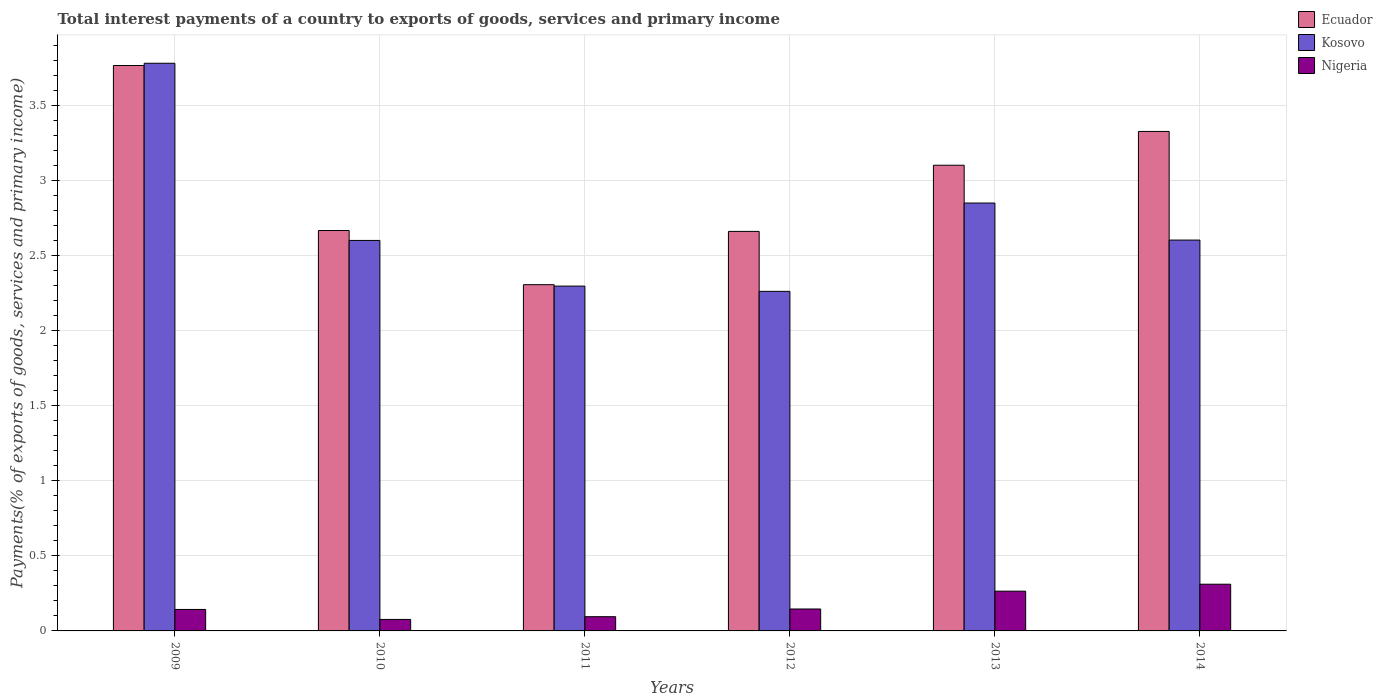Are the number of bars per tick equal to the number of legend labels?
Ensure brevity in your answer.  Yes. Are the number of bars on each tick of the X-axis equal?
Your answer should be compact. Yes. How many bars are there on the 6th tick from the left?
Your answer should be compact. 3. What is the total interest payments in Nigeria in 2009?
Offer a terse response. 0.14. Across all years, what is the maximum total interest payments in Ecuador?
Make the answer very short. 3.77. Across all years, what is the minimum total interest payments in Nigeria?
Offer a terse response. 0.08. In which year was the total interest payments in Nigeria maximum?
Your answer should be very brief. 2014. What is the total total interest payments in Nigeria in the graph?
Keep it short and to the point. 1.04. What is the difference between the total interest payments in Ecuador in 2012 and that in 2013?
Your response must be concise. -0.44. What is the difference between the total interest payments in Nigeria in 2011 and the total interest payments in Kosovo in 2012?
Your response must be concise. -2.17. What is the average total interest payments in Kosovo per year?
Offer a terse response. 2.73. In the year 2009, what is the difference between the total interest payments in Ecuador and total interest payments in Kosovo?
Your answer should be very brief. -0.02. What is the ratio of the total interest payments in Nigeria in 2009 to that in 2013?
Make the answer very short. 0.54. Is the total interest payments in Kosovo in 2009 less than that in 2014?
Give a very brief answer. No. Is the difference between the total interest payments in Ecuador in 2011 and 2013 greater than the difference between the total interest payments in Kosovo in 2011 and 2013?
Keep it short and to the point. No. What is the difference between the highest and the second highest total interest payments in Ecuador?
Your answer should be very brief. 0.44. What is the difference between the highest and the lowest total interest payments in Ecuador?
Keep it short and to the point. 1.46. In how many years, is the total interest payments in Ecuador greater than the average total interest payments in Ecuador taken over all years?
Offer a terse response. 3. Is the sum of the total interest payments in Ecuador in 2010 and 2014 greater than the maximum total interest payments in Kosovo across all years?
Give a very brief answer. Yes. What does the 3rd bar from the left in 2014 represents?
Your answer should be compact. Nigeria. What does the 3rd bar from the right in 2011 represents?
Your response must be concise. Ecuador. Is it the case that in every year, the sum of the total interest payments in Kosovo and total interest payments in Nigeria is greater than the total interest payments in Ecuador?
Provide a short and direct response. No. How many bars are there?
Provide a short and direct response. 18. Are all the bars in the graph horizontal?
Make the answer very short. No. How many years are there in the graph?
Your answer should be compact. 6. Does the graph contain any zero values?
Keep it short and to the point. No. Does the graph contain grids?
Make the answer very short. Yes. Where does the legend appear in the graph?
Provide a succinct answer. Top right. How are the legend labels stacked?
Give a very brief answer. Vertical. What is the title of the graph?
Offer a very short reply. Total interest payments of a country to exports of goods, services and primary income. What is the label or title of the X-axis?
Your response must be concise. Years. What is the label or title of the Y-axis?
Ensure brevity in your answer.  Payments(% of exports of goods, services and primary income). What is the Payments(% of exports of goods, services and primary income) in Ecuador in 2009?
Your answer should be very brief. 3.77. What is the Payments(% of exports of goods, services and primary income) of Kosovo in 2009?
Your response must be concise. 3.78. What is the Payments(% of exports of goods, services and primary income) of Nigeria in 2009?
Ensure brevity in your answer.  0.14. What is the Payments(% of exports of goods, services and primary income) in Ecuador in 2010?
Keep it short and to the point. 2.67. What is the Payments(% of exports of goods, services and primary income) of Kosovo in 2010?
Offer a terse response. 2.6. What is the Payments(% of exports of goods, services and primary income) of Nigeria in 2010?
Offer a terse response. 0.08. What is the Payments(% of exports of goods, services and primary income) of Ecuador in 2011?
Offer a terse response. 2.31. What is the Payments(% of exports of goods, services and primary income) of Kosovo in 2011?
Give a very brief answer. 2.3. What is the Payments(% of exports of goods, services and primary income) in Nigeria in 2011?
Your answer should be compact. 0.09. What is the Payments(% of exports of goods, services and primary income) in Ecuador in 2012?
Provide a short and direct response. 2.66. What is the Payments(% of exports of goods, services and primary income) of Kosovo in 2012?
Your answer should be compact. 2.26. What is the Payments(% of exports of goods, services and primary income) in Nigeria in 2012?
Provide a succinct answer. 0.15. What is the Payments(% of exports of goods, services and primary income) in Ecuador in 2013?
Provide a short and direct response. 3.1. What is the Payments(% of exports of goods, services and primary income) of Kosovo in 2013?
Keep it short and to the point. 2.85. What is the Payments(% of exports of goods, services and primary income) of Nigeria in 2013?
Your answer should be compact. 0.26. What is the Payments(% of exports of goods, services and primary income) of Ecuador in 2014?
Offer a terse response. 3.33. What is the Payments(% of exports of goods, services and primary income) in Kosovo in 2014?
Give a very brief answer. 2.61. What is the Payments(% of exports of goods, services and primary income) in Nigeria in 2014?
Offer a very short reply. 0.31. Across all years, what is the maximum Payments(% of exports of goods, services and primary income) of Ecuador?
Ensure brevity in your answer.  3.77. Across all years, what is the maximum Payments(% of exports of goods, services and primary income) in Kosovo?
Your response must be concise. 3.78. Across all years, what is the maximum Payments(% of exports of goods, services and primary income) of Nigeria?
Your answer should be very brief. 0.31. Across all years, what is the minimum Payments(% of exports of goods, services and primary income) in Ecuador?
Your answer should be compact. 2.31. Across all years, what is the minimum Payments(% of exports of goods, services and primary income) of Kosovo?
Your response must be concise. 2.26. Across all years, what is the minimum Payments(% of exports of goods, services and primary income) of Nigeria?
Keep it short and to the point. 0.08. What is the total Payments(% of exports of goods, services and primary income) of Ecuador in the graph?
Provide a succinct answer. 17.84. What is the total Payments(% of exports of goods, services and primary income) in Kosovo in the graph?
Your response must be concise. 16.41. What is the total Payments(% of exports of goods, services and primary income) of Nigeria in the graph?
Keep it short and to the point. 1.04. What is the difference between the Payments(% of exports of goods, services and primary income) of Ecuador in 2009 and that in 2010?
Offer a very short reply. 1.1. What is the difference between the Payments(% of exports of goods, services and primary income) in Kosovo in 2009 and that in 2010?
Offer a terse response. 1.18. What is the difference between the Payments(% of exports of goods, services and primary income) in Nigeria in 2009 and that in 2010?
Provide a short and direct response. 0.07. What is the difference between the Payments(% of exports of goods, services and primary income) of Ecuador in 2009 and that in 2011?
Keep it short and to the point. 1.46. What is the difference between the Payments(% of exports of goods, services and primary income) of Kosovo in 2009 and that in 2011?
Ensure brevity in your answer.  1.49. What is the difference between the Payments(% of exports of goods, services and primary income) in Nigeria in 2009 and that in 2011?
Provide a short and direct response. 0.05. What is the difference between the Payments(% of exports of goods, services and primary income) of Ecuador in 2009 and that in 2012?
Provide a succinct answer. 1.11. What is the difference between the Payments(% of exports of goods, services and primary income) in Kosovo in 2009 and that in 2012?
Your answer should be very brief. 1.52. What is the difference between the Payments(% of exports of goods, services and primary income) of Nigeria in 2009 and that in 2012?
Ensure brevity in your answer.  -0. What is the difference between the Payments(% of exports of goods, services and primary income) in Ecuador in 2009 and that in 2013?
Ensure brevity in your answer.  0.66. What is the difference between the Payments(% of exports of goods, services and primary income) of Kosovo in 2009 and that in 2013?
Make the answer very short. 0.93. What is the difference between the Payments(% of exports of goods, services and primary income) in Nigeria in 2009 and that in 2013?
Ensure brevity in your answer.  -0.12. What is the difference between the Payments(% of exports of goods, services and primary income) in Ecuador in 2009 and that in 2014?
Keep it short and to the point. 0.44. What is the difference between the Payments(% of exports of goods, services and primary income) in Kosovo in 2009 and that in 2014?
Make the answer very short. 1.18. What is the difference between the Payments(% of exports of goods, services and primary income) in Nigeria in 2009 and that in 2014?
Your answer should be compact. -0.17. What is the difference between the Payments(% of exports of goods, services and primary income) in Ecuador in 2010 and that in 2011?
Offer a very short reply. 0.36. What is the difference between the Payments(% of exports of goods, services and primary income) of Kosovo in 2010 and that in 2011?
Make the answer very short. 0.3. What is the difference between the Payments(% of exports of goods, services and primary income) in Nigeria in 2010 and that in 2011?
Offer a terse response. -0.02. What is the difference between the Payments(% of exports of goods, services and primary income) of Ecuador in 2010 and that in 2012?
Your answer should be very brief. 0.01. What is the difference between the Payments(% of exports of goods, services and primary income) of Kosovo in 2010 and that in 2012?
Offer a terse response. 0.34. What is the difference between the Payments(% of exports of goods, services and primary income) of Nigeria in 2010 and that in 2012?
Ensure brevity in your answer.  -0.07. What is the difference between the Payments(% of exports of goods, services and primary income) of Ecuador in 2010 and that in 2013?
Offer a very short reply. -0.44. What is the difference between the Payments(% of exports of goods, services and primary income) of Kosovo in 2010 and that in 2013?
Your answer should be compact. -0.25. What is the difference between the Payments(% of exports of goods, services and primary income) of Nigeria in 2010 and that in 2013?
Your answer should be very brief. -0.19. What is the difference between the Payments(% of exports of goods, services and primary income) of Ecuador in 2010 and that in 2014?
Keep it short and to the point. -0.66. What is the difference between the Payments(% of exports of goods, services and primary income) of Kosovo in 2010 and that in 2014?
Provide a succinct answer. -0. What is the difference between the Payments(% of exports of goods, services and primary income) in Nigeria in 2010 and that in 2014?
Provide a succinct answer. -0.23. What is the difference between the Payments(% of exports of goods, services and primary income) in Ecuador in 2011 and that in 2012?
Your answer should be very brief. -0.36. What is the difference between the Payments(% of exports of goods, services and primary income) in Kosovo in 2011 and that in 2012?
Give a very brief answer. 0.04. What is the difference between the Payments(% of exports of goods, services and primary income) in Nigeria in 2011 and that in 2012?
Make the answer very short. -0.05. What is the difference between the Payments(% of exports of goods, services and primary income) in Ecuador in 2011 and that in 2013?
Your answer should be compact. -0.8. What is the difference between the Payments(% of exports of goods, services and primary income) of Kosovo in 2011 and that in 2013?
Your response must be concise. -0.55. What is the difference between the Payments(% of exports of goods, services and primary income) in Nigeria in 2011 and that in 2013?
Keep it short and to the point. -0.17. What is the difference between the Payments(% of exports of goods, services and primary income) of Ecuador in 2011 and that in 2014?
Make the answer very short. -1.02. What is the difference between the Payments(% of exports of goods, services and primary income) of Kosovo in 2011 and that in 2014?
Keep it short and to the point. -0.31. What is the difference between the Payments(% of exports of goods, services and primary income) in Nigeria in 2011 and that in 2014?
Give a very brief answer. -0.22. What is the difference between the Payments(% of exports of goods, services and primary income) in Ecuador in 2012 and that in 2013?
Your answer should be compact. -0.44. What is the difference between the Payments(% of exports of goods, services and primary income) in Kosovo in 2012 and that in 2013?
Offer a very short reply. -0.59. What is the difference between the Payments(% of exports of goods, services and primary income) in Nigeria in 2012 and that in 2013?
Keep it short and to the point. -0.12. What is the difference between the Payments(% of exports of goods, services and primary income) of Ecuador in 2012 and that in 2014?
Make the answer very short. -0.67. What is the difference between the Payments(% of exports of goods, services and primary income) of Kosovo in 2012 and that in 2014?
Give a very brief answer. -0.34. What is the difference between the Payments(% of exports of goods, services and primary income) in Nigeria in 2012 and that in 2014?
Offer a terse response. -0.17. What is the difference between the Payments(% of exports of goods, services and primary income) in Ecuador in 2013 and that in 2014?
Keep it short and to the point. -0.23. What is the difference between the Payments(% of exports of goods, services and primary income) in Kosovo in 2013 and that in 2014?
Your response must be concise. 0.25. What is the difference between the Payments(% of exports of goods, services and primary income) of Nigeria in 2013 and that in 2014?
Ensure brevity in your answer.  -0.05. What is the difference between the Payments(% of exports of goods, services and primary income) in Ecuador in 2009 and the Payments(% of exports of goods, services and primary income) in Kosovo in 2010?
Provide a short and direct response. 1.17. What is the difference between the Payments(% of exports of goods, services and primary income) in Ecuador in 2009 and the Payments(% of exports of goods, services and primary income) in Nigeria in 2010?
Make the answer very short. 3.69. What is the difference between the Payments(% of exports of goods, services and primary income) in Kosovo in 2009 and the Payments(% of exports of goods, services and primary income) in Nigeria in 2010?
Offer a terse response. 3.71. What is the difference between the Payments(% of exports of goods, services and primary income) of Ecuador in 2009 and the Payments(% of exports of goods, services and primary income) of Kosovo in 2011?
Offer a terse response. 1.47. What is the difference between the Payments(% of exports of goods, services and primary income) in Ecuador in 2009 and the Payments(% of exports of goods, services and primary income) in Nigeria in 2011?
Offer a terse response. 3.67. What is the difference between the Payments(% of exports of goods, services and primary income) of Kosovo in 2009 and the Payments(% of exports of goods, services and primary income) of Nigeria in 2011?
Offer a terse response. 3.69. What is the difference between the Payments(% of exports of goods, services and primary income) of Ecuador in 2009 and the Payments(% of exports of goods, services and primary income) of Kosovo in 2012?
Provide a short and direct response. 1.51. What is the difference between the Payments(% of exports of goods, services and primary income) of Ecuador in 2009 and the Payments(% of exports of goods, services and primary income) of Nigeria in 2012?
Your answer should be very brief. 3.62. What is the difference between the Payments(% of exports of goods, services and primary income) in Kosovo in 2009 and the Payments(% of exports of goods, services and primary income) in Nigeria in 2012?
Provide a short and direct response. 3.64. What is the difference between the Payments(% of exports of goods, services and primary income) in Ecuador in 2009 and the Payments(% of exports of goods, services and primary income) in Nigeria in 2013?
Your response must be concise. 3.5. What is the difference between the Payments(% of exports of goods, services and primary income) of Kosovo in 2009 and the Payments(% of exports of goods, services and primary income) of Nigeria in 2013?
Ensure brevity in your answer.  3.52. What is the difference between the Payments(% of exports of goods, services and primary income) in Ecuador in 2009 and the Payments(% of exports of goods, services and primary income) in Kosovo in 2014?
Your answer should be compact. 1.16. What is the difference between the Payments(% of exports of goods, services and primary income) in Ecuador in 2009 and the Payments(% of exports of goods, services and primary income) in Nigeria in 2014?
Your answer should be very brief. 3.46. What is the difference between the Payments(% of exports of goods, services and primary income) of Kosovo in 2009 and the Payments(% of exports of goods, services and primary income) of Nigeria in 2014?
Offer a very short reply. 3.47. What is the difference between the Payments(% of exports of goods, services and primary income) of Ecuador in 2010 and the Payments(% of exports of goods, services and primary income) of Kosovo in 2011?
Offer a very short reply. 0.37. What is the difference between the Payments(% of exports of goods, services and primary income) of Ecuador in 2010 and the Payments(% of exports of goods, services and primary income) of Nigeria in 2011?
Give a very brief answer. 2.57. What is the difference between the Payments(% of exports of goods, services and primary income) in Kosovo in 2010 and the Payments(% of exports of goods, services and primary income) in Nigeria in 2011?
Provide a succinct answer. 2.51. What is the difference between the Payments(% of exports of goods, services and primary income) of Ecuador in 2010 and the Payments(% of exports of goods, services and primary income) of Kosovo in 2012?
Make the answer very short. 0.41. What is the difference between the Payments(% of exports of goods, services and primary income) in Ecuador in 2010 and the Payments(% of exports of goods, services and primary income) in Nigeria in 2012?
Provide a short and direct response. 2.52. What is the difference between the Payments(% of exports of goods, services and primary income) in Kosovo in 2010 and the Payments(% of exports of goods, services and primary income) in Nigeria in 2012?
Offer a terse response. 2.46. What is the difference between the Payments(% of exports of goods, services and primary income) of Ecuador in 2010 and the Payments(% of exports of goods, services and primary income) of Kosovo in 2013?
Offer a very short reply. -0.18. What is the difference between the Payments(% of exports of goods, services and primary income) of Ecuador in 2010 and the Payments(% of exports of goods, services and primary income) of Nigeria in 2013?
Give a very brief answer. 2.4. What is the difference between the Payments(% of exports of goods, services and primary income) of Kosovo in 2010 and the Payments(% of exports of goods, services and primary income) of Nigeria in 2013?
Ensure brevity in your answer.  2.34. What is the difference between the Payments(% of exports of goods, services and primary income) in Ecuador in 2010 and the Payments(% of exports of goods, services and primary income) in Kosovo in 2014?
Ensure brevity in your answer.  0.06. What is the difference between the Payments(% of exports of goods, services and primary income) in Ecuador in 2010 and the Payments(% of exports of goods, services and primary income) in Nigeria in 2014?
Your response must be concise. 2.36. What is the difference between the Payments(% of exports of goods, services and primary income) of Kosovo in 2010 and the Payments(% of exports of goods, services and primary income) of Nigeria in 2014?
Provide a short and direct response. 2.29. What is the difference between the Payments(% of exports of goods, services and primary income) in Ecuador in 2011 and the Payments(% of exports of goods, services and primary income) in Kosovo in 2012?
Your response must be concise. 0.04. What is the difference between the Payments(% of exports of goods, services and primary income) of Ecuador in 2011 and the Payments(% of exports of goods, services and primary income) of Nigeria in 2012?
Provide a short and direct response. 2.16. What is the difference between the Payments(% of exports of goods, services and primary income) of Kosovo in 2011 and the Payments(% of exports of goods, services and primary income) of Nigeria in 2012?
Give a very brief answer. 2.15. What is the difference between the Payments(% of exports of goods, services and primary income) in Ecuador in 2011 and the Payments(% of exports of goods, services and primary income) in Kosovo in 2013?
Make the answer very short. -0.54. What is the difference between the Payments(% of exports of goods, services and primary income) of Ecuador in 2011 and the Payments(% of exports of goods, services and primary income) of Nigeria in 2013?
Make the answer very short. 2.04. What is the difference between the Payments(% of exports of goods, services and primary income) in Kosovo in 2011 and the Payments(% of exports of goods, services and primary income) in Nigeria in 2013?
Your answer should be compact. 2.03. What is the difference between the Payments(% of exports of goods, services and primary income) in Ecuador in 2011 and the Payments(% of exports of goods, services and primary income) in Kosovo in 2014?
Keep it short and to the point. -0.3. What is the difference between the Payments(% of exports of goods, services and primary income) in Ecuador in 2011 and the Payments(% of exports of goods, services and primary income) in Nigeria in 2014?
Provide a short and direct response. 2. What is the difference between the Payments(% of exports of goods, services and primary income) of Kosovo in 2011 and the Payments(% of exports of goods, services and primary income) of Nigeria in 2014?
Ensure brevity in your answer.  1.99. What is the difference between the Payments(% of exports of goods, services and primary income) in Ecuador in 2012 and the Payments(% of exports of goods, services and primary income) in Kosovo in 2013?
Make the answer very short. -0.19. What is the difference between the Payments(% of exports of goods, services and primary income) in Ecuador in 2012 and the Payments(% of exports of goods, services and primary income) in Nigeria in 2013?
Your answer should be very brief. 2.4. What is the difference between the Payments(% of exports of goods, services and primary income) of Kosovo in 2012 and the Payments(% of exports of goods, services and primary income) of Nigeria in 2013?
Ensure brevity in your answer.  2. What is the difference between the Payments(% of exports of goods, services and primary income) in Ecuador in 2012 and the Payments(% of exports of goods, services and primary income) in Kosovo in 2014?
Provide a succinct answer. 0.06. What is the difference between the Payments(% of exports of goods, services and primary income) in Ecuador in 2012 and the Payments(% of exports of goods, services and primary income) in Nigeria in 2014?
Provide a succinct answer. 2.35. What is the difference between the Payments(% of exports of goods, services and primary income) in Kosovo in 2012 and the Payments(% of exports of goods, services and primary income) in Nigeria in 2014?
Your response must be concise. 1.95. What is the difference between the Payments(% of exports of goods, services and primary income) in Ecuador in 2013 and the Payments(% of exports of goods, services and primary income) in Kosovo in 2014?
Ensure brevity in your answer.  0.5. What is the difference between the Payments(% of exports of goods, services and primary income) in Ecuador in 2013 and the Payments(% of exports of goods, services and primary income) in Nigeria in 2014?
Provide a succinct answer. 2.79. What is the difference between the Payments(% of exports of goods, services and primary income) of Kosovo in 2013 and the Payments(% of exports of goods, services and primary income) of Nigeria in 2014?
Give a very brief answer. 2.54. What is the average Payments(% of exports of goods, services and primary income) in Ecuador per year?
Your answer should be compact. 2.97. What is the average Payments(% of exports of goods, services and primary income) in Kosovo per year?
Your response must be concise. 2.73. What is the average Payments(% of exports of goods, services and primary income) of Nigeria per year?
Offer a terse response. 0.17. In the year 2009, what is the difference between the Payments(% of exports of goods, services and primary income) of Ecuador and Payments(% of exports of goods, services and primary income) of Kosovo?
Ensure brevity in your answer.  -0.01. In the year 2009, what is the difference between the Payments(% of exports of goods, services and primary income) in Ecuador and Payments(% of exports of goods, services and primary income) in Nigeria?
Your answer should be very brief. 3.63. In the year 2009, what is the difference between the Payments(% of exports of goods, services and primary income) in Kosovo and Payments(% of exports of goods, services and primary income) in Nigeria?
Give a very brief answer. 3.64. In the year 2010, what is the difference between the Payments(% of exports of goods, services and primary income) in Ecuador and Payments(% of exports of goods, services and primary income) in Kosovo?
Your answer should be very brief. 0.07. In the year 2010, what is the difference between the Payments(% of exports of goods, services and primary income) in Ecuador and Payments(% of exports of goods, services and primary income) in Nigeria?
Provide a succinct answer. 2.59. In the year 2010, what is the difference between the Payments(% of exports of goods, services and primary income) of Kosovo and Payments(% of exports of goods, services and primary income) of Nigeria?
Offer a terse response. 2.53. In the year 2011, what is the difference between the Payments(% of exports of goods, services and primary income) of Ecuador and Payments(% of exports of goods, services and primary income) of Kosovo?
Ensure brevity in your answer.  0.01. In the year 2011, what is the difference between the Payments(% of exports of goods, services and primary income) in Ecuador and Payments(% of exports of goods, services and primary income) in Nigeria?
Keep it short and to the point. 2.21. In the year 2011, what is the difference between the Payments(% of exports of goods, services and primary income) of Kosovo and Payments(% of exports of goods, services and primary income) of Nigeria?
Your response must be concise. 2.2. In the year 2012, what is the difference between the Payments(% of exports of goods, services and primary income) in Ecuador and Payments(% of exports of goods, services and primary income) in Kosovo?
Your answer should be compact. 0.4. In the year 2012, what is the difference between the Payments(% of exports of goods, services and primary income) in Ecuador and Payments(% of exports of goods, services and primary income) in Nigeria?
Your answer should be very brief. 2.52. In the year 2012, what is the difference between the Payments(% of exports of goods, services and primary income) in Kosovo and Payments(% of exports of goods, services and primary income) in Nigeria?
Your answer should be compact. 2.12. In the year 2013, what is the difference between the Payments(% of exports of goods, services and primary income) of Ecuador and Payments(% of exports of goods, services and primary income) of Kosovo?
Make the answer very short. 0.25. In the year 2013, what is the difference between the Payments(% of exports of goods, services and primary income) of Ecuador and Payments(% of exports of goods, services and primary income) of Nigeria?
Ensure brevity in your answer.  2.84. In the year 2013, what is the difference between the Payments(% of exports of goods, services and primary income) in Kosovo and Payments(% of exports of goods, services and primary income) in Nigeria?
Keep it short and to the point. 2.59. In the year 2014, what is the difference between the Payments(% of exports of goods, services and primary income) of Ecuador and Payments(% of exports of goods, services and primary income) of Kosovo?
Give a very brief answer. 0.72. In the year 2014, what is the difference between the Payments(% of exports of goods, services and primary income) in Ecuador and Payments(% of exports of goods, services and primary income) in Nigeria?
Provide a short and direct response. 3.02. In the year 2014, what is the difference between the Payments(% of exports of goods, services and primary income) of Kosovo and Payments(% of exports of goods, services and primary income) of Nigeria?
Make the answer very short. 2.29. What is the ratio of the Payments(% of exports of goods, services and primary income) of Ecuador in 2009 to that in 2010?
Offer a terse response. 1.41. What is the ratio of the Payments(% of exports of goods, services and primary income) of Kosovo in 2009 to that in 2010?
Keep it short and to the point. 1.45. What is the ratio of the Payments(% of exports of goods, services and primary income) in Nigeria in 2009 to that in 2010?
Provide a succinct answer. 1.87. What is the ratio of the Payments(% of exports of goods, services and primary income) in Ecuador in 2009 to that in 2011?
Offer a very short reply. 1.63. What is the ratio of the Payments(% of exports of goods, services and primary income) of Kosovo in 2009 to that in 2011?
Your answer should be very brief. 1.65. What is the ratio of the Payments(% of exports of goods, services and primary income) in Nigeria in 2009 to that in 2011?
Provide a succinct answer. 1.51. What is the ratio of the Payments(% of exports of goods, services and primary income) in Ecuador in 2009 to that in 2012?
Provide a short and direct response. 1.42. What is the ratio of the Payments(% of exports of goods, services and primary income) of Kosovo in 2009 to that in 2012?
Provide a succinct answer. 1.67. What is the ratio of the Payments(% of exports of goods, services and primary income) in Nigeria in 2009 to that in 2012?
Give a very brief answer. 0.98. What is the ratio of the Payments(% of exports of goods, services and primary income) in Ecuador in 2009 to that in 2013?
Offer a very short reply. 1.21. What is the ratio of the Payments(% of exports of goods, services and primary income) in Kosovo in 2009 to that in 2013?
Your answer should be compact. 1.33. What is the ratio of the Payments(% of exports of goods, services and primary income) in Nigeria in 2009 to that in 2013?
Your answer should be compact. 0.54. What is the ratio of the Payments(% of exports of goods, services and primary income) in Ecuador in 2009 to that in 2014?
Give a very brief answer. 1.13. What is the ratio of the Payments(% of exports of goods, services and primary income) of Kosovo in 2009 to that in 2014?
Give a very brief answer. 1.45. What is the ratio of the Payments(% of exports of goods, services and primary income) of Nigeria in 2009 to that in 2014?
Keep it short and to the point. 0.46. What is the ratio of the Payments(% of exports of goods, services and primary income) of Ecuador in 2010 to that in 2011?
Your answer should be very brief. 1.16. What is the ratio of the Payments(% of exports of goods, services and primary income) of Kosovo in 2010 to that in 2011?
Your answer should be compact. 1.13. What is the ratio of the Payments(% of exports of goods, services and primary income) in Nigeria in 2010 to that in 2011?
Provide a succinct answer. 0.81. What is the ratio of the Payments(% of exports of goods, services and primary income) of Ecuador in 2010 to that in 2012?
Make the answer very short. 1. What is the ratio of the Payments(% of exports of goods, services and primary income) in Kosovo in 2010 to that in 2012?
Give a very brief answer. 1.15. What is the ratio of the Payments(% of exports of goods, services and primary income) of Nigeria in 2010 to that in 2012?
Provide a short and direct response. 0.52. What is the ratio of the Payments(% of exports of goods, services and primary income) in Ecuador in 2010 to that in 2013?
Provide a short and direct response. 0.86. What is the ratio of the Payments(% of exports of goods, services and primary income) in Kosovo in 2010 to that in 2013?
Offer a terse response. 0.91. What is the ratio of the Payments(% of exports of goods, services and primary income) in Nigeria in 2010 to that in 2013?
Offer a terse response. 0.29. What is the ratio of the Payments(% of exports of goods, services and primary income) of Ecuador in 2010 to that in 2014?
Provide a succinct answer. 0.8. What is the ratio of the Payments(% of exports of goods, services and primary income) in Nigeria in 2010 to that in 2014?
Make the answer very short. 0.25. What is the ratio of the Payments(% of exports of goods, services and primary income) in Ecuador in 2011 to that in 2012?
Your answer should be compact. 0.87. What is the ratio of the Payments(% of exports of goods, services and primary income) of Kosovo in 2011 to that in 2012?
Offer a very short reply. 1.02. What is the ratio of the Payments(% of exports of goods, services and primary income) in Nigeria in 2011 to that in 2012?
Provide a short and direct response. 0.65. What is the ratio of the Payments(% of exports of goods, services and primary income) of Ecuador in 2011 to that in 2013?
Your response must be concise. 0.74. What is the ratio of the Payments(% of exports of goods, services and primary income) of Kosovo in 2011 to that in 2013?
Your answer should be very brief. 0.81. What is the ratio of the Payments(% of exports of goods, services and primary income) of Nigeria in 2011 to that in 2013?
Offer a terse response. 0.36. What is the ratio of the Payments(% of exports of goods, services and primary income) in Ecuador in 2011 to that in 2014?
Offer a very short reply. 0.69. What is the ratio of the Payments(% of exports of goods, services and primary income) of Kosovo in 2011 to that in 2014?
Your answer should be very brief. 0.88. What is the ratio of the Payments(% of exports of goods, services and primary income) of Nigeria in 2011 to that in 2014?
Your answer should be very brief. 0.3. What is the ratio of the Payments(% of exports of goods, services and primary income) of Ecuador in 2012 to that in 2013?
Your answer should be very brief. 0.86. What is the ratio of the Payments(% of exports of goods, services and primary income) in Kosovo in 2012 to that in 2013?
Make the answer very short. 0.79. What is the ratio of the Payments(% of exports of goods, services and primary income) of Nigeria in 2012 to that in 2013?
Your answer should be very brief. 0.55. What is the ratio of the Payments(% of exports of goods, services and primary income) of Ecuador in 2012 to that in 2014?
Ensure brevity in your answer.  0.8. What is the ratio of the Payments(% of exports of goods, services and primary income) in Kosovo in 2012 to that in 2014?
Your answer should be compact. 0.87. What is the ratio of the Payments(% of exports of goods, services and primary income) of Nigeria in 2012 to that in 2014?
Ensure brevity in your answer.  0.47. What is the ratio of the Payments(% of exports of goods, services and primary income) in Ecuador in 2013 to that in 2014?
Your answer should be compact. 0.93. What is the ratio of the Payments(% of exports of goods, services and primary income) of Kosovo in 2013 to that in 2014?
Keep it short and to the point. 1.09. What is the ratio of the Payments(% of exports of goods, services and primary income) in Nigeria in 2013 to that in 2014?
Give a very brief answer. 0.85. What is the difference between the highest and the second highest Payments(% of exports of goods, services and primary income) of Ecuador?
Ensure brevity in your answer.  0.44. What is the difference between the highest and the second highest Payments(% of exports of goods, services and primary income) in Kosovo?
Provide a short and direct response. 0.93. What is the difference between the highest and the second highest Payments(% of exports of goods, services and primary income) of Nigeria?
Offer a very short reply. 0.05. What is the difference between the highest and the lowest Payments(% of exports of goods, services and primary income) of Ecuador?
Ensure brevity in your answer.  1.46. What is the difference between the highest and the lowest Payments(% of exports of goods, services and primary income) of Kosovo?
Offer a very short reply. 1.52. What is the difference between the highest and the lowest Payments(% of exports of goods, services and primary income) of Nigeria?
Make the answer very short. 0.23. 